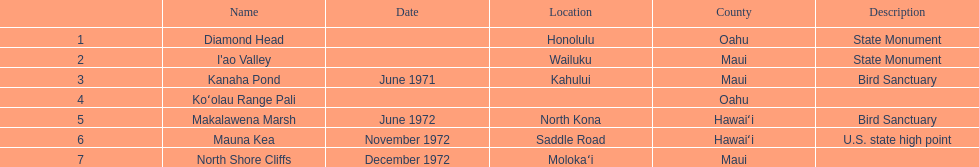Could you help me parse every detail presented in this table? {'header': ['', 'Name', 'Date', 'Location', 'County', 'Description'], 'rows': [['1', 'Diamond Head', '', 'Honolulu', 'Oahu', 'State Monument'], ['2', "I'ao Valley", '', 'Wailuku', 'Maui', 'State Monument'], ['3', 'Kanaha Pond', 'June 1971', 'Kahului', 'Maui', 'Bird Sanctuary'], ['4', 'Koʻolau Range Pali', '', '', 'Oahu', ''], ['5', 'Makalawena Marsh', 'June 1972', 'North Kona', 'Hawaiʻi', 'Bird Sanctuary'], ['6', 'Mauna Kea', 'November 1972', 'Saddle Road', 'Hawaiʻi', 'U.S. state high point'], ['7', 'North Shore Cliffs', 'December 1972', 'Molokaʻi', 'Maui', '']]} Other than mauna kea, name a place in hawaii. Makalawena Marsh. 